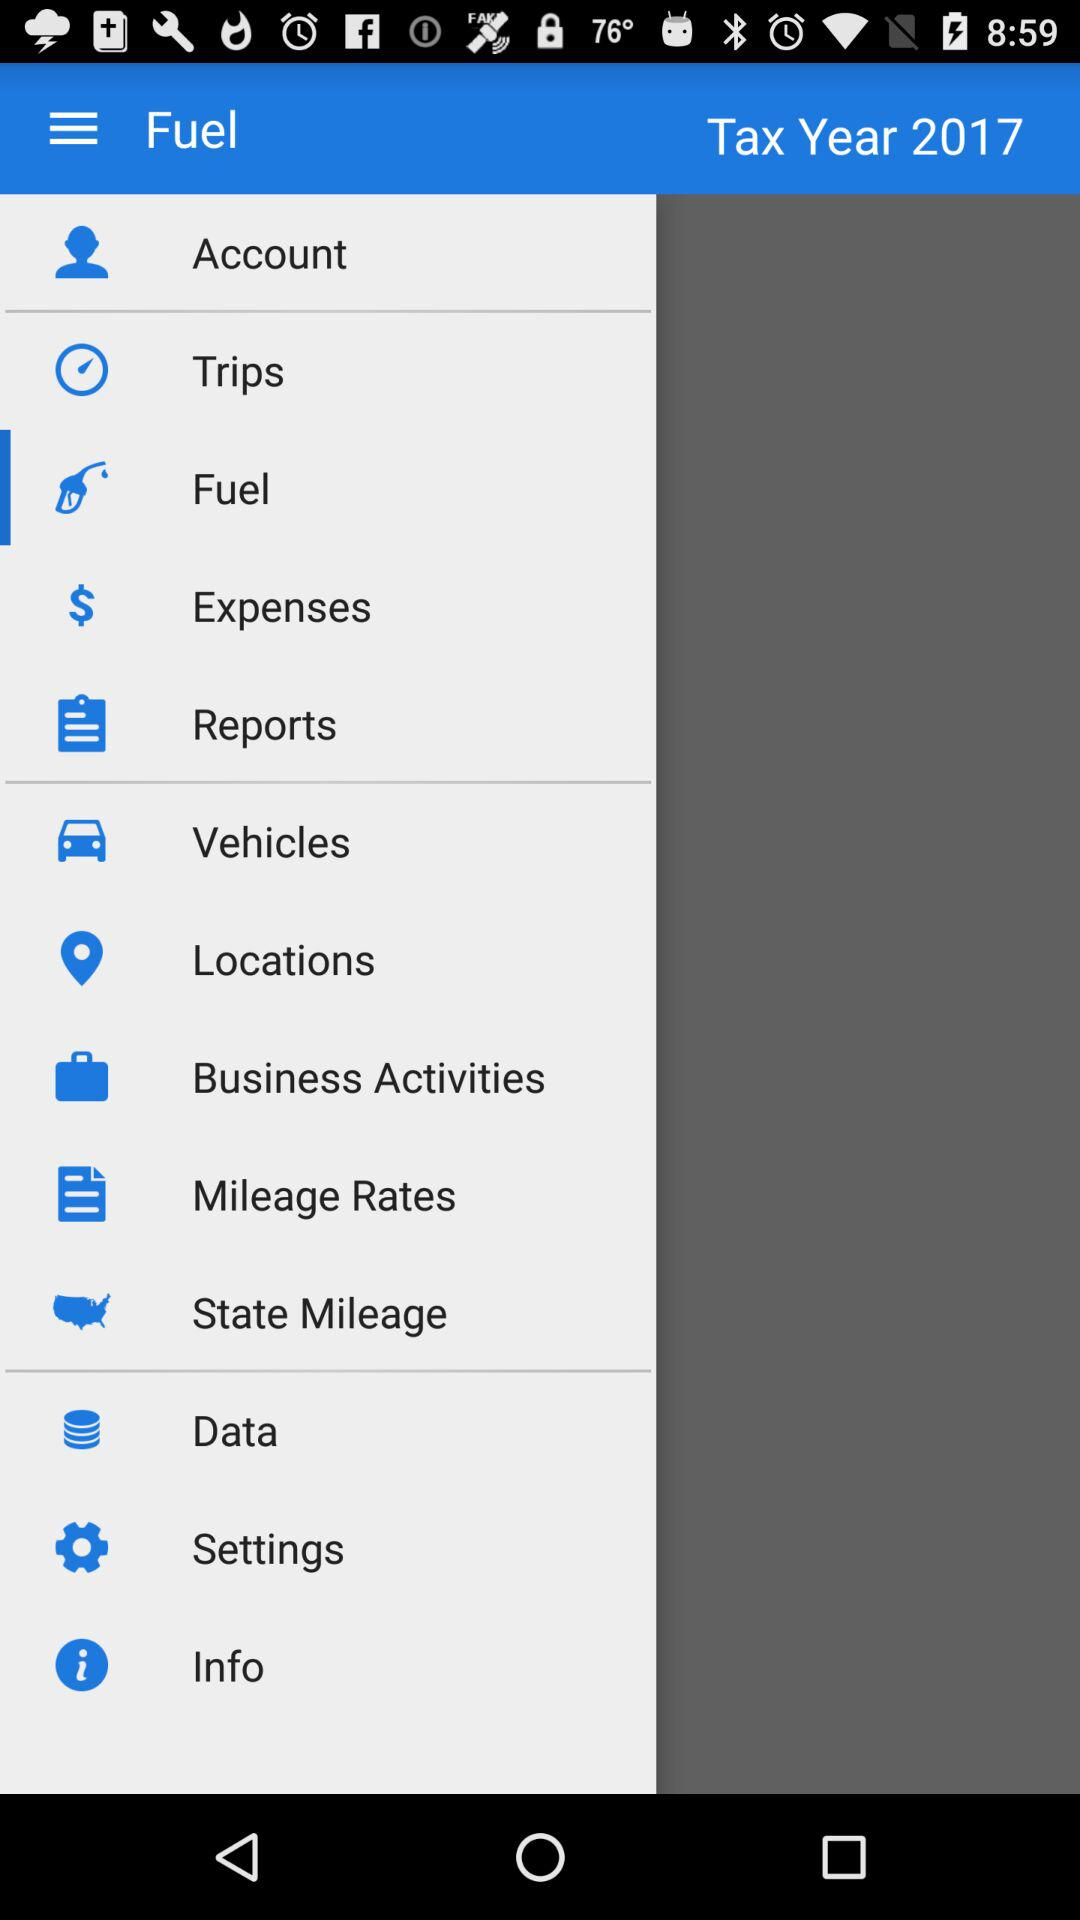What is the tax year? The tax year is 2017. 